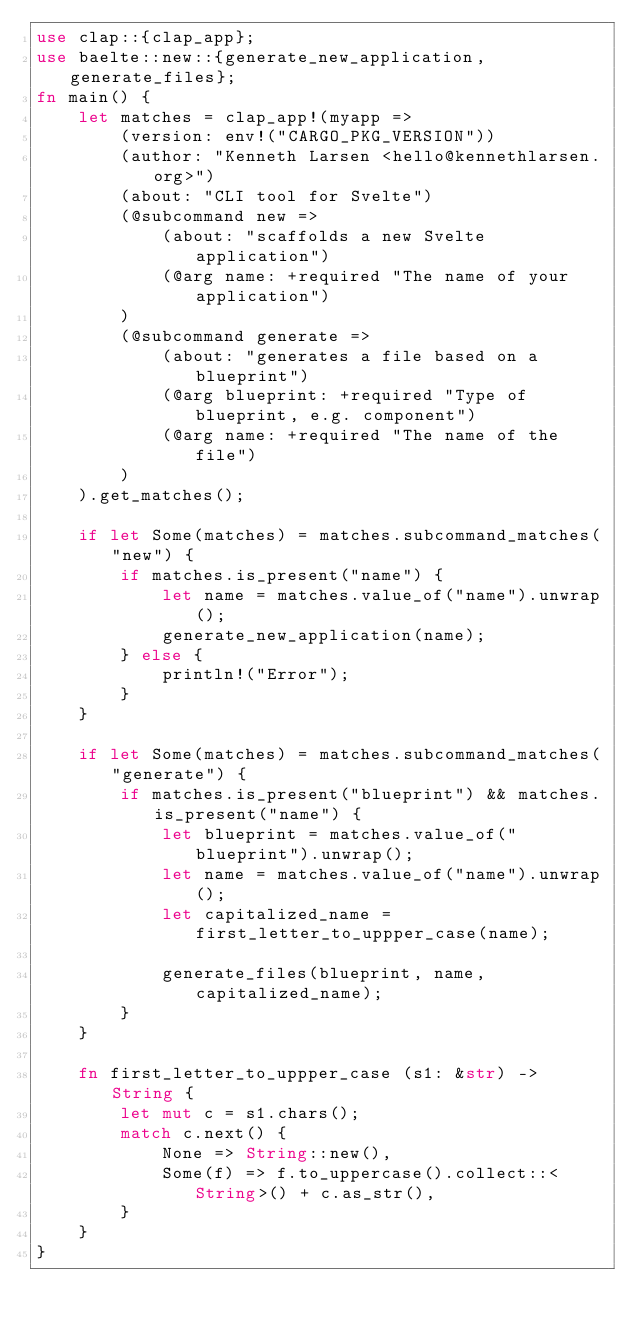Convert code to text. <code><loc_0><loc_0><loc_500><loc_500><_Rust_>use clap::{clap_app};
use baelte::new::{generate_new_application, generate_files};
fn main() {
    let matches = clap_app!(myapp =>
        (version: env!("CARGO_PKG_VERSION"))
        (author: "Kenneth Larsen <hello@kennethlarsen.org>")
        (about: "CLI tool for Svelte")
        (@subcommand new =>
            (about: "scaffolds a new Svelte application")
            (@arg name: +required "The name of your application")
        )
        (@subcommand generate =>
            (about: "generates a file based on a blueprint")
            (@arg blueprint: +required "Type of blueprint, e.g. component")
            (@arg name: +required "The name of the file")
        )
    ).get_matches();

    if let Some(matches) = matches.subcommand_matches("new") {
        if matches.is_present("name") {
            let name = matches.value_of("name").unwrap();
            generate_new_application(name);
        } else {
            println!("Error");
        }
    }

    if let Some(matches) = matches.subcommand_matches("generate") {
        if matches.is_present("blueprint") && matches.is_present("name") {
            let blueprint = matches.value_of("blueprint").unwrap(); 
            let name = matches.value_of("name").unwrap();
            let capitalized_name = first_letter_to_uppper_case(name);

            generate_files(blueprint, name, capitalized_name);
        }
    }

    fn first_letter_to_uppper_case (s1: &str) -> String {
        let mut c = s1.chars();
        match c.next() {
            None => String::new(),
            Some(f) => f.to_uppercase().collect::<String>() + c.as_str(),
        }
    }
}</code> 